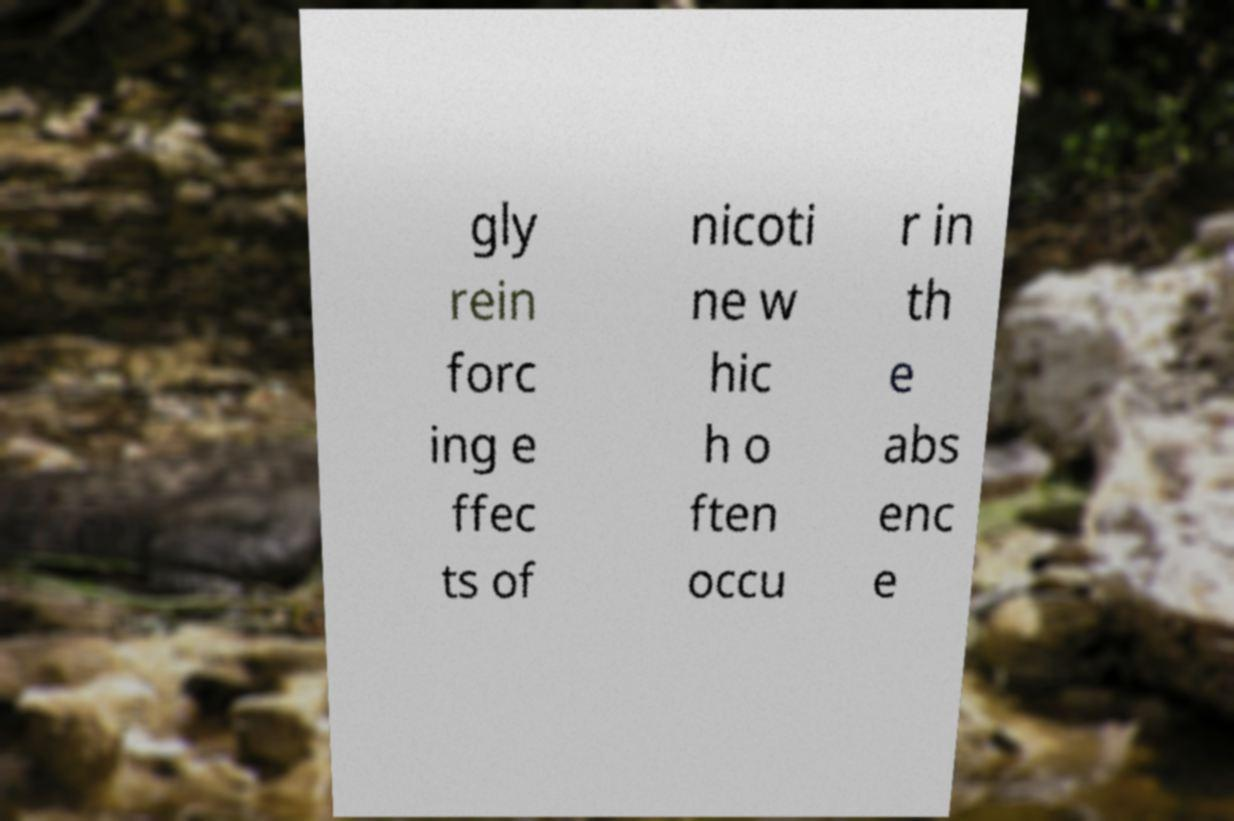Please identify and transcribe the text found in this image. gly rein forc ing e ffec ts of nicoti ne w hic h o ften occu r in th e abs enc e 